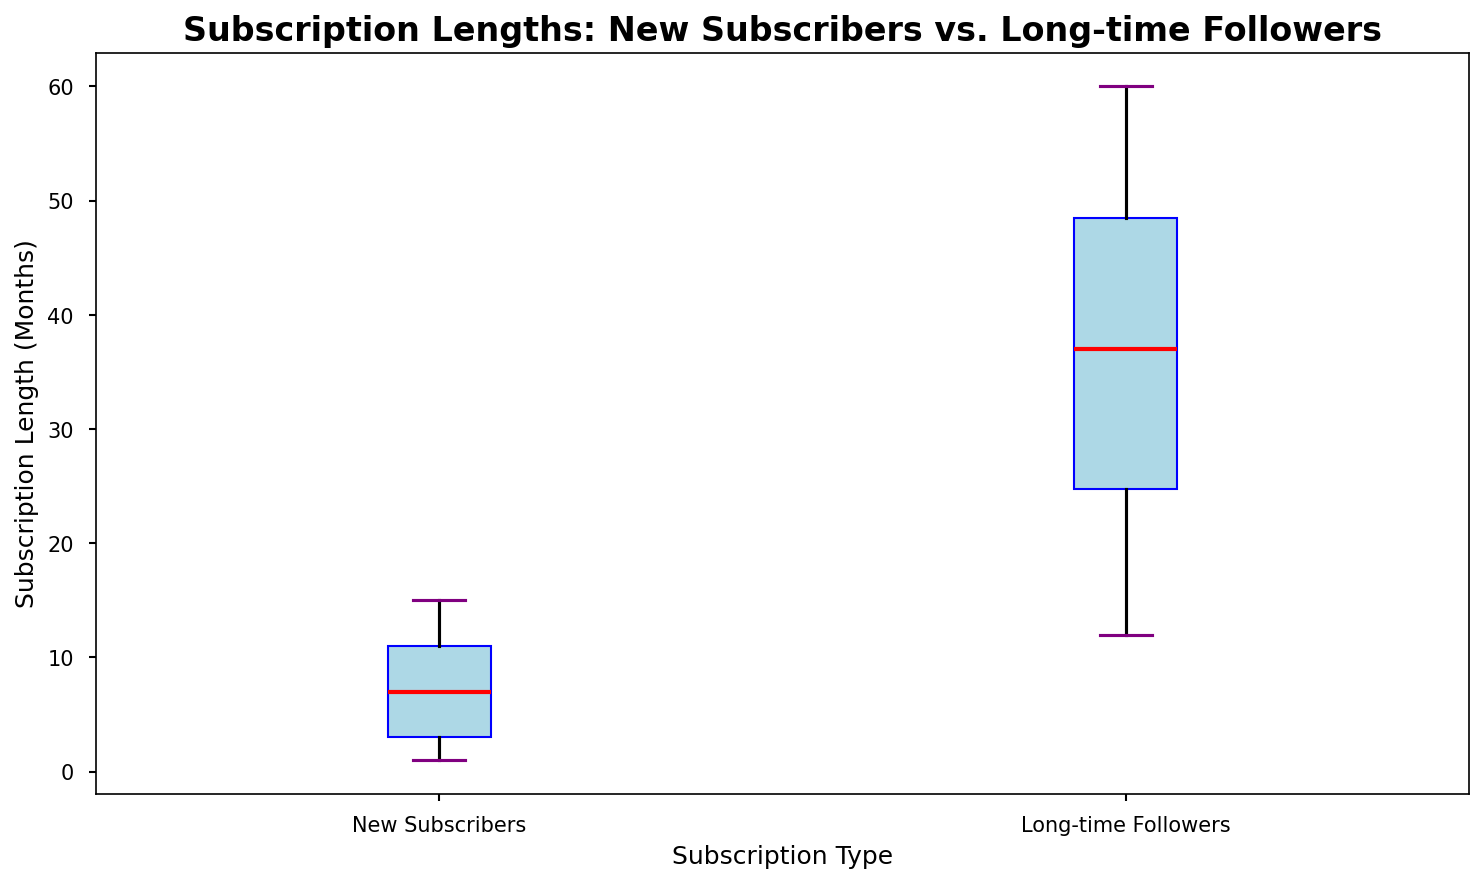What's the median subscription length for new subscribers? The boxplot shows the median value of the new subscribers as a red line inside the blue box. For the new subscribers, the red line is at 7.
Answer: 7 What is the interquartile range (IQR) of subscription lengths for long-time followers? The IQR is the difference between the 75th percentile (top edge of the box) and the 25th percentile (bottom edge of the box). For long-time followers, the top edge of the box is at 45 months, and the bottom is at 24 months. The IQR = 45 - 24 = 21 months.
Answer: 21 Which group has the highest median subscription length, and what is it? The red line inside the box represents the median. The median for long-time followers is higher than for new subscribers. The median for long-time followers is 38 months.
Answer: Long-time followers, 38 How do the ranges of subscription lengths (from minimum to maximum) compare between the two groups? For new subscribers, the range is from the lowest whisker (1 month) to the highest whisker (15 months). For long-time followers, it extends from the lowest whisker (12 months) to the highest whisker (60 months). The range for long-time followers is much broader.
Answer: Long-time followers have a broader range What can be said about the outliers in either group? Outliers are typically shown as individual points beyond the whiskers. In the box plot, new subscribers and long-time followers don't seem to have noticeable outliers as no individual points are marked significantly outside the whiskers.
Answer: No noticeable outliers in both groups Which group shows a higher variability in subscription lengths? Variability is often inferred from the length of the whiskers and the size of the IQR box. Long-time followers have longer whiskers and a larger IQR box than new subscribers, indicating higher variability.
Answer: Long-time followers What's the subscription length of the 25th percentile for new subscribers? The bottom edge of the blue box represents the 25th percentile. For new subscribers, this edge is at 3 months.
Answer: 3 If an unknown subscriber has a subscription length of 50 months, which group are they most likely part of? Given that the maximum subscription length for new subscribers is below 50 months, a subscriber with 50 months is likely part of the long-time followers group.
Answer: Long-time followers What visual feature indicates the median on this box plot? The median is indicated by a red line within the box for each group.
Answer: Red line inside the box 